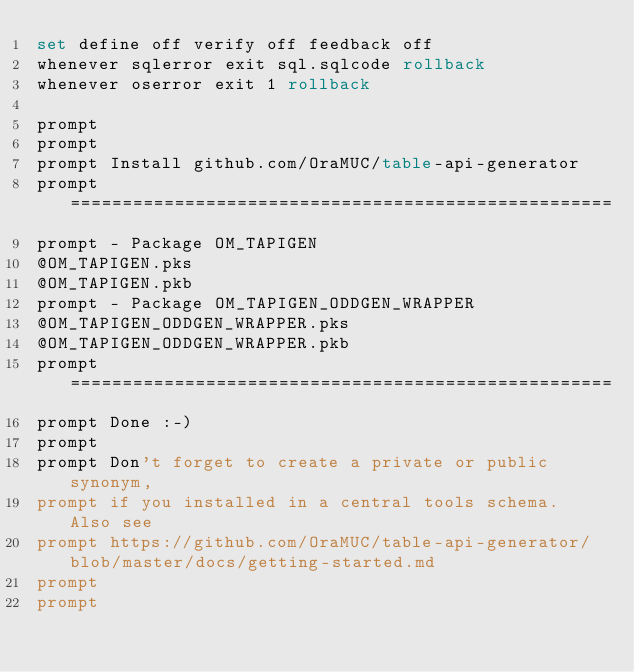<code> <loc_0><loc_0><loc_500><loc_500><_SQL_>set define off verify off feedback off
whenever sqlerror exit sql.sqlcode rollback
whenever oserror exit 1 rollback

prompt
prompt
prompt Install github.com/OraMUC/table-api-generator
prompt ====================================================
prompt - Package OM_TAPIGEN
@OM_TAPIGEN.pks
@OM_TAPIGEN.pkb
prompt - Package OM_TAPIGEN_ODDGEN_WRAPPER
@OM_TAPIGEN_ODDGEN_WRAPPER.pks
@OM_TAPIGEN_ODDGEN_WRAPPER.pkb
prompt ====================================================
prompt Done :-)
prompt
prompt Don't forget to create a private or public synonym, 
prompt if you installed in a central tools schema. Also see
prompt https://github.com/OraMUC/table-api-generator/blob/master/docs/getting-started.md
prompt
prompt
</code> 